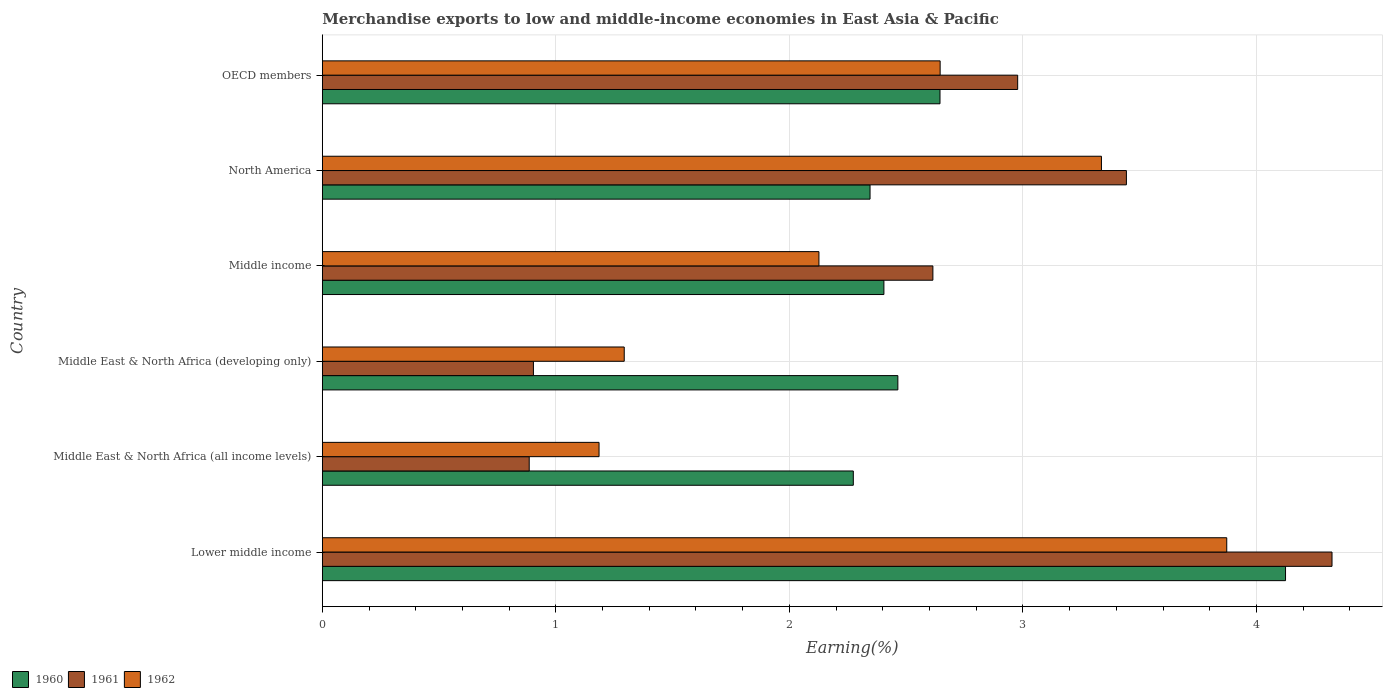Are the number of bars on each tick of the Y-axis equal?
Give a very brief answer. Yes. How many bars are there on the 5th tick from the top?
Your response must be concise. 3. How many bars are there on the 6th tick from the bottom?
Provide a succinct answer. 3. What is the label of the 6th group of bars from the top?
Keep it short and to the point. Lower middle income. What is the percentage of amount earned from merchandise exports in 1960 in Lower middle income?
Ensure brevity in your answer.  4.12. Across all countries, what is the maximum percentage of amount earned from merchandise exports in 1961?
Your response must be concise. 4.32. Across all countries, what is the minimum percentage of amount earned from merchandise exports in 1962?
Your answer should be compact. 1.19. In which country was the percentage of amount earned from merchandise exports in 1962 maximum?
Provide a short and direct response. Lower middle income. In which country was the percentage of amount earned from merchandise exports in 1962 minimum?
Offer a very short reply. Middle East & North Africa (all income levels). What is the total percentage of amount earned from merchandise exports in 1962 in the graph?
Offer a very short reply. 14.46. What is the difference between the percentage of amount earned from merchandise exports in 1961 in Middle East & North Africa (all income levels) and that in Middle income?
Your answer should be very brief. -1.73. What is the difference between the percentage of amount earned from merchandise exports in 1961 in Lower middle income and the percentage of amount earned from merchandise exports in 1960 in North America?
Keep it short and to the point. 1.98. What is the average percentage of amount earned from merchandise exports in 1962 per country?
Your response must be concise. 2.41. What is the difference between the percentage of amount earned from merchandise exports in 1962 and percentage of amount earned from merchandise exports in 1961 in OECD members?
Keep it short and to the point. -0.33. In how many countries, is the percentage of amount earned from merchandise exports in 1960 greater than 0.6000000000000001 %?
Your answer should be compact. 6. What is the ratio of the percentage of amount earned from merchandise exports in 1962 in Lower middle income to that in North America?
Offer a very short reply. 1.16. Is the percentage of amount earned from merchandise exports in 1961 in Middle East & North Africa (developing only) less than that in North America?
Ensure brevity in your answer.  Yes. What is the difference between the highest and the second highest percentage of amount earned from merchandise exports in 1961?
Your answer should be very brief. 0.88. What is the difference between the highest and the lowest percentage of amount earned from merchandise exports in 1962?
Your answer should be compact. 2.69. In how many countries, is the percentage of amount earned from merchandise exports in 1960 greater than the average percentage of amount earned from merchandise exports in 1960 taken over all countries?
Your answer should be compact. 1. Is the sum of the percentage of amount earned from merchandise exports in 1960 in Middle East & North Africa (all income levels) and Middle income greater than the maximum percentage of amount earned from merchandise exports in 1961 across all countries?
Your response must be concise. Yes. Are all the bars in the graph horizontal?
Ensure brevity in your answer.  Yes. How many countries are there in the graph?
Your answer should be compact. 6. What is the difference between two consecutive major ticks on the X-axis?
Your answer should be very brief. 1. Are the values on the major ticks of X-axis written in scientific E-notation?
Your answer should be compact. No. Where does the legend appear in the graph?
Your answer should be very brief. Bottom left. What is the title of the graph?
Make the answer very short. Merchandise exports to low and middle-income economies in East Asia & Pacific. Does "1975" appear as one of the legend labels in the graph?
Your answer should be compact. No. What is the label or title of the X-axis?
Give a very brief answer. Earning(%). What is the Earning(%) of 1960 in Lower middle income?
Keep it short and to the point. 4.12. What is the Earning(%) of 1961 in Lower middle income?
Provide a succinct answer. 4.32. What is the Earning(%) in 1962 in Lower middle income?
Your response must be concise. 3.87. What is the Earning(%) in 1960 in Middle East & North Africa (all income levels)?
Offer a very short reply. 2.27. What is the Earning(%) in 1961 in Middle East & North Africa (all income levels)?
Make the answer very short. 0.89. What is the Earning(%) in 1962 in Middle East & North Africa (all income levels)?
Provide a short and direct response. 1.19. What is the Earning(%) of 1960 in Middle East & North Africa (developing only)?
Your answer should be compact. 2.46. What is the Earning(%) in 1961 in Middle East & North Africa (developing only)?
Your answer should be compact. 0.9. What is the Earning(%) of 1962 in Middle East & North Africa (developing only)?
Your answer should be compact. 1.29. What is the Earning(%) in 1960 in Middle income?
Your answer should be very brief. 2.4. What is the Earning(%) of 1961 in Middle income?
Give a very brief answer. 2.61. What is the Earning(%) of 1962 in Middle income?
Offer a very short reply. 2.13. What is the Earning(%) in 1960 in North America?
Your response must be concise. 2.35. What is the Earning(%) of 1961 in North America?
Offer a terse response. 3.44. What is the Earning(%) in 1962 in North America?
Offer a terse response. 3.34. What is the Earning(%) of 1960 in OECD members?
Provide a short and direct response. 2.65. What is the Earning(%) of 1961 in OECD members?
Make the answer very short. 2.98. What is the Earning(%) in 1962 in OECD members?
Offer a very short reply. 2.65. Across all countries, what is the maximum Earning(%) in 1960?
Ensure brevity in your answer.  4.12. Across all countries, what is the maximum Earning(%) of 1961?
Your answer should be compact. 4.32. Across all countries, what is the maximum Earning(%) in 1962?
Keep it short and to the point. 3.87. Across all countries, what is the minimum Earning(%) in 1960?
Your answer should be very brief. 2.27. Across all countries, what is the minimum Earning(%) in 1961?
Provide a short and direct response. 0.89. Across all countries, what is the minimum Earning(%) of 1962?
Your answer should be compact. 1.19. What is the total Earning(%) in 1960 in the graph?
Ensure brevity in your answer.  16.26. What is the total Earning(%) in 1961 in the graph?
Keep it short and to the point. 15.15. What is the total Earning(%) of 1962 in the graph?
Offer a very short reply. 14.46. What is the difference between the Earning(%) in 1960 in Lower middle income and that in Middle East & North Africa (all income levels)?
Offer a very short reply. 1.85. What is the difference between the Earning(%) of 1961 in Lower middle income and that in Middle East & North Africa (all income levels)?
Keep it short and to the point. 3.44. What is the difference between the Earning(%) of 1962 in Lower middle income and that in Middle East & North Africa (all income levels)?
Keep it short and to the point. 2.69. What is the difference between the Earning(%) of 1960 in Lower middle income and that in Middle East & North Africa (developing only)?
Your answer should be compact. 1.66. What is the difference between the Earning(%) of 1961 in Lower middle income and that in Middle East & North Africa (developing only)?
Offer a terse response. 3.42. What is the difference between the Earning(%) of 1962 in Lower middle income and that in Middle East & North Africa (developing only)?
Make the answer very short. 2.58. What is the difference between the Earning(%) in 1960 in Lower middle income and that in Middle income?
Offer a terse response. 1.72. What is the difference between the Earning(%) in 1961 in Lower middle income and that in Middle income?
Make the answer very short. 1.71. What is the difference between the Earning(%) in 1962 in Lower middle income and that in Middle income?
Provide a short and direct response. 1.75. What is the difference between the Earning(%) in 1960 in Lower middle income and that in North America?
Offer a terse response. 1.78. What is the difference between the Earning(%) of 1961 in Lower middle income and that in North America?
Offer a terse response. 0.88. What is the difference between the Earning(%) in 1962 in Lower middle income and that in North America?
Make the answer very short. 0.54. What is the difference between the Earning(%) of 1960 in Lower middle income and that in OECD members?
Your response must be concise. 1.48. What is the difference between the Earning(%) in 1961 in Lower middle income and that in OECD members?
Offer a terse response. 1.35. What is the difference between the Earning(%) of 1962 in Lower middle income and that in OECD members?
Ensure brevity in your answer.  1.23. What is the difference between the Earning(%) of 1960 in Middle East & North Africa (all income levels) and that in Middle East & North Africa (developing only)?
Offer a terse response. -0.19. What is the difference between the Earning(%) of 1961 in Middle East & North Africa (all income levels) and that in Middle East & North Africa (developing only)?
Provide a succinct answer. -0.02. What is the difference between the Earning(%) of 1962 in Middle East & North Africa (all income levels) and that in Middle East & North Africa (developing only)?
Make the answer very short. -0.11. What is the difference between the Earning(%) in 1960 in Middle East & North Africa (all income levels) and that in Middle income?
Make the answer very short. -0.13. What is the difference between the Earning(%) in 1961 in Middle East & North Africa (all income levels) and that in Middle income?
Your response must be concise. -1.73. What is the difference between the Earning(%) of 1962 in Middle East & North Africa (all income levels) and that in Middle income?
Offer a very short reply. -0.94. What is the difference between the Earning(%) of 1960 in Middle East & North Africa (all income levels) and that in North America?
Provide a short and direct response. -0.07. What is the difference between the Earning(%) of 1961 in Middle East & North Africa (all income levels) and that in North America?
Offer a very short reply. -2.56. What is the difference between the Earning(%) of 1962 in Middle East & North Africa (all income levels) and that in North America?
Your answer should be compact. -2.15. What is the difference between the Earning(%) in 1960 in Middle East & North Africa (all income levels) and that in OECD members?
Provide a short and direct response. -0.37. What is the difference between the Earning(%) in 1961 in Middle East & North Africa (all income levels) and that in OECD members?
Your response must be concise. -2.09. What is the difference between the Earning(%) in 1962 in Middle East & North Africa (all income levels) and that in OECD members?
Provide a succinct answer. -1.46. What is the difference between the Earning(%) in 1960 in Middle East & North Africa (developing only) and that in Middle income?
Offer a very short reply. 0.06. What is the difference between the Earning(%) of 1961 in Middle East & North Africa (developing only) and that in Middle income?
Your response must be concise. -1.71. What is the difference between the Earning(%) of 1962 in Middle East & North Africa (developing only) and that in Middle income?
Your answer should be compact. -0.83. What is the difference between the Earning(%) in 1960 in Middle East & North Africa (developing only) and that in North America?
Make the answer very short. 0.12. What is the difference between the Earning(%) of 1961 in Middle East & North Africa (developing only) and that in North America?
Keep it short and to the point. -2.54. What is the difference between the Earning(%) in 1962 in Middle East & North Africa (developing only) and that in North America?
Offer a terse response. -2.04. What is the difference between the Earning(%) in 1960 in Middle East & North Africa (developing only) and that in OECD members?
Keep it short and to the point. -0.18. What is the difference between the Earning(%) in 1961 in Middle East & North Africa (developing only) and that in OECD members?
Offer a very short reply. -2.07. What is the difference between the Earning(%) of 1962 in Middle East & North Africa (developing only) and that in OECD members?
Make the answer very short. -1.35. What is the difference between the Earning(%) of 1960 in Middle income and that in North America?
Your response must be concise. 0.06. What is the difference between the Earning(%) of 1961 in Middle income and that in North America?
Your answer should be very brief. -0.83. What is the difference between the Earning(%) of 1962 in Middle income and that in North America?
Provide a succinct answer. -1.21. What is the difference between the Earning(%) in 1960 in Middle income and that in OECD members?
Keep it short and to the point. -0.24. What is the difference between the Earning(%) of 1961 in Middle income and that in OECD members?
Your answer should be very brief. -0.36. What is the difference between the Earning(%) of 1962 in Middle income and that in OECD members?
Ensure brevity in your answer.  -0.52. What is the difference between the Earning(%) of 1960 in North America and that in OECD members?
Provide a short and direct response. -0.3. What is the difference between the Earning(%) of 1961 in North America and that in OECD members?
Offer a terse response. 0.47. What is the difference between the Earning(%) of 1962 in North America and that in OECD members?
Give a very brief answer. 0.69. What is the difference between the Earning(%) in 1960 in Lower middle income and the Earning(%) in 1961 in Middle East & North Africa (all income levels)?
Provide a short and direct response. 3.24. What is the difference between the Earning(%) in 1960 in Lower middle income and the Earning(%) in 1962 in Middle East & North Africa (all income levels)?
Your response must be concise. 2.94. What is the difference between the Earning(%) of 1961 in Lower middle income and the Earning(%) of 1962 in Middle East & North Africa (all income levels)?
Give a very brief answer. 3.14. What is the difference between the Earning(%) in 1960 in Lower middle income and the Earning(%) in 1961 in Middle East & North Africa (developing only)?
Provide a succinct answer. 3.22. What is the difference between the Earning(%) in 1960 in Lower middle income and the Earning(%) in 1962 in Middle East & North Africa (developing only)?
Offer a very short reply. 2.83. What is the difference between the Earning(%) in 1961 in Lower middle income and the Earning(%) in 1962 in Middle East & North Africa (developing only)?
Provide a short and direct response. 3.03. What is the difference between the Earning(%) of 1960 in Lower middle income and the Earning(%) of 1961 in Middle income?
Offer a terse response. 1.51. What is the difference between the Earning(%) of 1960 in Lower middle income and the Earning(%) of 1962 in Middle income?
Provide a succinct answer. 2. What is the difference between the Earning(%) in 1961 in Lower middle income and the Earning(%) in 1962 in Middle income?
Provide a short and direct response. 2.2. What is the difference between the Earning(%) of 1960 in Lower middle income and the Earning(%) of 1961 in North America?
Provide a short and direct response. 0.68. What is the difference between the Earning(%) in 1960 in Lower middle income and the Earning(%) in 1962 in North America?
Your answer should be very brief. 0.79. What is the difference between the Earning(%) in 1961 in Lower middle income and the Earning(%) in 1962 in North America?
Keep it short and to the point. 0.99. What is the difference between the Earning(%) of 1960 in Lower middle income and the Earning(%) of 1961 in OECD members?
Your answer should be compact. 1.15. What is the difference between the Earning(%) of 1960 in Lower middle income and the Earning(%) of 1962 in OECD members?
Provide a short and direct response. 1.48. What is the difference between the Earning(%) in 1961 in Lower middle income and the Earning(%) in 1962 in OECD members?
Your answer should be very brief. 1.68. What is the difference between the Earning(%) in 1960 in Middle East & North Africa (all income levels) and the Earning(%) in 1961 in Middle East & North Africa (developing only)?
Make the answer very short. 1.37. What is the difference between the Earning(%) in 1960 in Middle East & North Africa (all income levels) and the Earning(%) in 1962 in Middle East & North Africa (developing only)?
Your response must be concise. 0.98. What is the difference between the Earning(%) in 1961 in Middle East & North Africa (all income levels) and the Earning(%) in 1962 in Middle East & North Africa (developing only)?
Offer a very short reply. -0.41. What is the difference between the Earning(%) in 1960 in Middle East & North Africa (all income levels) and the Earning(%) in 1961 in Middle income?
Your response must be concise. -0.34. What is the difference between the Earning(%) of 1960 in Middle East & North Africa (all income levels) and the Earning(%) of 1962 in Middle income?
Your response must be concise. 0.15. What is the difference between the Earning(%) of 1961 in Middle East & North Africa (all income levels) and the Earning(%) of 1962 in Middle income?
Provide a succinct answer. -1.24. What is the difference between the Earning(%) in 1960 in Middle East & North Africa (all income levels) and the Earning(%) in 1961 in North America?
Provide a short and direct response. -1.17. What is the difference between the Earning(%) in 1960 in Middle East & North Africa (all income levels) and the Earning(%) in 1962 in North America?
Make the answer very short. -1.06. What is the difference between the Earning(%) of 1961 in Middle East & North Africa (all income levels) and the Earning(%) of 1962 in North America?
Your answer should be compact. -2.45. What is the difference between the Earning(%) of 1960 in Middle East & North Africa (all income levels) and the Earning(%) of 1961 in OECD members?
Your answer should be compact. -0.7. What is the difference between the Earning(%) in 1960 in Middle East & North Africa (all income levels) and the Earning(%) in 1962 in OECD members?
Give a very brief answer. -0.37. What is the difference between the Earning(%) of 1961 in Middle East & North Africa (all income levels) and the Earning(%) of 1962 in OECD members?
Provide a succinct answer. -1.76. What is the difference between the Earning(%) of 1960 in Middle East & North Africa (developing only) and the Earning(%) of 1962 in Middle income?
Your response must be concise. 0.34. What is the difference between the Earning(%) in 1961 in Middle East & North Africa (developing only) and the Earning(%) in 1962 in Middle income?
Provide a short and direct response. -1.22. What is the difference between the Earning(%) of 1960 in Middle East & North Africa (developing only) and the Earning(%) of 1961 in North America?
Your answer should be very brief. -0.98. What is the difference between the Earning(%) in 1960 in Middle East & North Africa (developing only) and the Earning(%) in 1962 in North America?
Keep it short and to the point. -0.87. What is the difference between the Earning(%) of 1961 in Middle East & North Africa (developing only) and the Earning(%) of 1962 in North America?
Your answer should be very brief. -2.43. What is the difference between the Earning(%) in 1960 in Middle East & North Africa (developing only) and the Earning(%) in 1961 in OECD members?
Make the answer very short. -0.51. What is the difference between the Earning(%) of 1960 in Middle East & North Africa (developing only) and the Earning(%) of 1962 in OECD members?
Ensure brevity in your answer.  -0.18. What is the difference between the Earning(%) in 1961 in Middle East & North Africa (developing only) and the Earning(%) in 1962 in OECD members?
Your response must be concise. -1.74. What is the difference between the Earning(%) in 1960 in Middle income and the Earning(%) in 1961 in North America?
Offer a terse response. -1.04. What is the difference between the Earning(%) of 1960 in Middle income and the Earning(%) of 1962 in North America?
Ensure brevity in your answer.  -0.93. What is the difference between the Earning(%) in 1961 in Middle income and the Earning(%) in 1962 in North America?
Offer a very short reply. -0.72. What is the difference between the Earning(%) in 1960 in Middle income and the Earning(%) in 1961 in OECD members?
Your response must be concise. -0.57. What is the difference between the Earning(%) of 1960 in Middle income and the Earning(%) of 1962 in OECD members?
Offer a very short reply. -0.24. What is the difference between the Earning(%) of 1961 in Middle income and the Earning(%) of 1962 in OECD members?
Provide a short and direct response. -0.03. What is the difference between the Earning(%) of 1960 in North America and the Earning(%) of 1961 in OECD members?
Offer a very short reply. -0.63. What is the difference between the Earning(%) in 1960 in North America and the Earning(%) in 1962 in OECD members?
Your response must be concise. -0.3. What is the difference between the Earning(%) in 1961 in North America and the Earning(%) in 1962 in OECD members?
Provide a succinct answer. 0.8. What is the average Earning(%) of 1960 per country?
Ensure brevity in your answer.  2.71. What is the average Earning(%) in 1961 per country?
Provide a short and direct response. 2.52. What is the average Earning(%) of 1962 per country?
Offer a terse response. 2.41. What is the difference between the Earning(%) of 1960 and Earning(%) of 1961 in Lower middle income?
Ensure brevity in your answer.  -0.2. What is the difference between the Earning(%) in 1960 and Earning(%) in 1962 in Lower middle income?
Your answer should be very brief. 0.25. What is the difference between the Earning(%) in 1961 and Earning(%) in 1962 in Lower middle income?
Provide a short and direct response. 0.45. What is the difference between the Earning(%) of 1960 and Earning(%) of 1961 in Middle East & North Africa (all income levels)?
Offer a very short reply. 1.39. What is the difference between the Earning(%) in 1960 and Earning(%) in 1962 in Middle East & North Africa (all income levels)?
Keep it short and to the point. 1.09. What is the difference between the Earning(%) of 1961 and Earning(%) of 1962 in Middle East & North Africa (all income levels)?
Make the answer very short. -0.3. What is the difference between the Earning(%) in 1960 and Earning(%) in 1961 in Middle East & North Africa (developing only)?
Make the answer very short. 1.56. What is the difference between the Earning(%) of 1960 and Earning(%) of 1962 in Middle East & North Africa (developing only)?
Offer a terse response. 1.17. What is the difference between the Earning(%) in 1961 and Earning(%) in 1962 in Middle East & North Africa (developing only)?
Your answer should be compact. -0.39. What is the difference between the Earning(%) of 1960 and Earning(%) of 1961 in Middle income?
Provide a short and direct response. -0.21. What is the difference between the Earning(%) of 1960 and Earning(%) of 1962 in Middle income?
Your answer should be very brief. 0.28. What is the difference between the Earning(%) of 1961 and Earning(%) of 1962 in Middle income?
Your response must be concise. 0.49. What is the difference between the Earning(%) of 1960 and Earning(%) of 1961 in North America?
Your answer should be very brief. -1.1. What is the difference between the Earning(%) in 1960 and Earning(%) in 1962 in North America?
Provide a succinct answer. -0.99. What is the difference between the Earning(%) of 1961 and Earning(%) of 1962 in North America?
Your answer should be compact. 0.11. What is the difference between the Earning(%) of 1960 and Earning(%) of 1961 in OECD members?
Provide a short and direct response. -0.33. What is the difference between the Earning(%) in 1960 and Earning(%) in 1962 in OECD members?
Your answer should be compact. -0. What is the difference between the Earning(%) of 1961 and Earning(%) of 1962 in OECD members?
Your answer should be compact. 0.33. What is the ratio of the Earning(%) in 1960 in Lower middle income to that in Middle East & North Africa (all income levels)?
Your answer should be compact. 1.81. What is the ratio of the Earning(%) of 1961 in Lower middle income to that in Middle East & North Africa (all income levels)?
Offer a very short reply. 4.88. What is the ratio of the Earning(%) in 1962 in Lower middle income to that in Middle East & North Africa (all income levels)?
Your answer should be compact. 3.27. What is the ratio of the Earning(%) in 1960 in Lower middle income to that in Middle East & North Africa (developing only)?
Give a very brief answer. 1.67. What is the ratio of the Earning(%) of 1961 in Lower middle income to that in Middle East & North Africa (developing only)?
Your answer should be compact. 4.78. What is the ratio of the Earning(%) of 1962 in Lower middle income to that in Middle East & North Africa (developing only)?
Ensure brevity in your answer.  3. What is the ratio of the Earning(%) in 1960 in Lower middle income to that in Middle income?
Provide a short and direct response. 1.72. What is the ratio of the Earning(%) in 1961 in Lower middle income to that in Middle income?
Keep it short and to the point. 1.65. What is the ratio of the Earning(%) of 1962 in Lower middle income to that in Middle income?
Your response must be concise. 1.82. What is the ratio of the Earning(%) of 1960 in Lower middle income to that in North America?
Keep it short and to the point. 1.76. What is the ratio of the Earning(%) of 1961 in Lower middle income to that in North America?
Ensure brevity in your answer.  1.26. What is the ratio of the Earning(%) of 1962 in Lower middle income to that in North America?
Keep it short and to the point. 1.16. What is the ratio of the Earning(%) in 1960 in Lower middle income to that in OECD members?
Give a very brief answer. 1.56. What is the ratio of the Earning(%) of 1961 in Lower middle income to that in OECD members?
Keep it short and to the point. 1.45. What is the ratio of the Earning(%) in 1962 in Lower middle income to that in OECD members?
Your response must be concise. 1.46. What is the ratio of the Earning(%) in 1960 in Middle East & North Africa (all income levels) to that in Middle East & North Africa (developing only)?
Make the answer very short. 0.92. What is the ratio of the Earning(%) in 1961 in Middle East & North Africa (all income levels) to that in Middle East & North Africa (developing only)?
Your response must be concise. 0.98. What is the ratio of the Earning(%) of 1962 in Middle East & North Africa (all income levels) to that in Middle East & North Africa (developing only)?
Your answer should be compact. 0.92. What is the ratio of the Earning(%) in 1960 in Middle East & North Africa (all income levels) to that in Middle income?
Your response must be concise. 0.95. What is the ratio of the Earning(%) in 1961 in Middle East & North Africa (all income levels) to that in Middle income?
Make the answer very short. 0.34. What is the ratio of the Earning(%) in 1962 in Middle East & North Africa (all income levels) to that in Middle income?
Make the answer very short. 0.56. What is the ratio of the Earning(%) in 1960 in Middle East & North Africa (all income levels) to that in North America?
Your response must be concise. 0.97. What is the ratio of the Earning(%) in 1961 in Middle East & North Africa (all income levels) to that in North America?
Provide a short and direct response. 0.26. What is the ratio of the Earning(%) of 1962 in Middle East & North Africa (all income levels) to that in North America?
Keep it short and to the point. 0.36. What is the ratio of the Earning(%) in 1960 in Middle East & North Africa (all income levels) to that in OECD members?
Ensure brevity in your answer.  0.86. What is the ratio of the Earning(%) in 1961 in Middle East & North Africa (all income levels) to that in OECD members?
Ensure brevity in your answer.  0.3. What is the ratio of the Earning(%) in 1962 in Middle East & North Africa (all income levels) to that in OECD members?
Provide a succinct answer. 0.45. What is the ratio of the Earning(%) of 1960 in Middle East & North Africa (developing only) to that in Middle income?
Give a very brief answer. 1.02. What is the ratio of the Earning(%) in 1961 in Middle East & North Africa (developing only) to that in Middle income?
Make the answer very short. 0.35. What is the ratio of the Earning(%) in 1962 in Middle East & North Africa (developing only) to that in Middle income?
Ensure brevity in your answer.  0.61. What is the ratio of the Earning(%) of 1960 in Middle East & North Africa (developing only) to that in North America?
Your answer should be compact. 1.05. What is the ratio of the Earning(%) in 1961 in Middle East & North Africa (developing only) to that in North America?
Give a very brief answer. 0.26. What is the ratio of the Earning(%) in 1962 in Middle East & North Africa (developing only) to that in North America?
Offer a very short reply. 0.39. What is the ratio of the Earning(%) in 1960 in Middle East & North Africa (developing only) to that in OECD members?
Offer a terse response. 0.93. What is the ratio of the Earning(%) of 1961 in Middle East & North Africa (developing only) to that in OECD members?
Your answer should be very brief. 0.3. What is the ratio of the Earning(%) of 1962 in Middle East & North Africa (developing only) to that in OECD members?
Make the answer very short. 0.49. What is the ratio of the Earning(%) of 1960 in Middle income to that in North America?
Your answer should be very brief. 1.03. What is the ratio of the Earning(%) in 1961 in Middle income to that in North America?
Your answer should be very brief. 0.76. What is the ratio of the Earning(%) in 1962 in Middle income to that in North America?
Give a very brief answer. 0.64. What is the ratio of the Earning(%) in 1960 in Middle income to that in OECD members?
Make the answer very short. 0.91. What is the ratio of the Earning(%) of 1961 in Middle income to that in OECD members?
Your answer should be compact. 0.88. What is the ratio of the Earning(%) in 1962 in Middle income to that in OECD members?
Offer a very short reply. 0.8. What is the ratio of the Earning(%) in 1960 in North America to that in OECD members?
Your response must be concise. 0.89. What is the ratio of the Earning(%) in 1961 in North America to that in OECD members?
Provide a short and direct response. 1.16. What is the ratio of the Earning(%) in 1962 in North America to that in OECD members?
Offer a very short reply. 1.26. What is the difference between the highest and the second highest Earning(%) of 1960?
Ensure brevity in your answer.  1.48. What is the difference between the highest and the second highest Earning(%) in 1961?
Your response must be concise. 0.88. What is the difference between the highest and the second highest Earning(%) of 1962?
Ensure brevity in your answer.  0.54. What is the difference between the highest and the lowest Earning(%) of 1960?
Ensure brevity in your answer.  1.85. What is the difference between the highest and the lowest Earning(%) of 1961?
Your answer should be compact. 3.44. What is the difference between the highest and the lowest Earning(%) of 1962?
Make the answer very short. 2.69. 